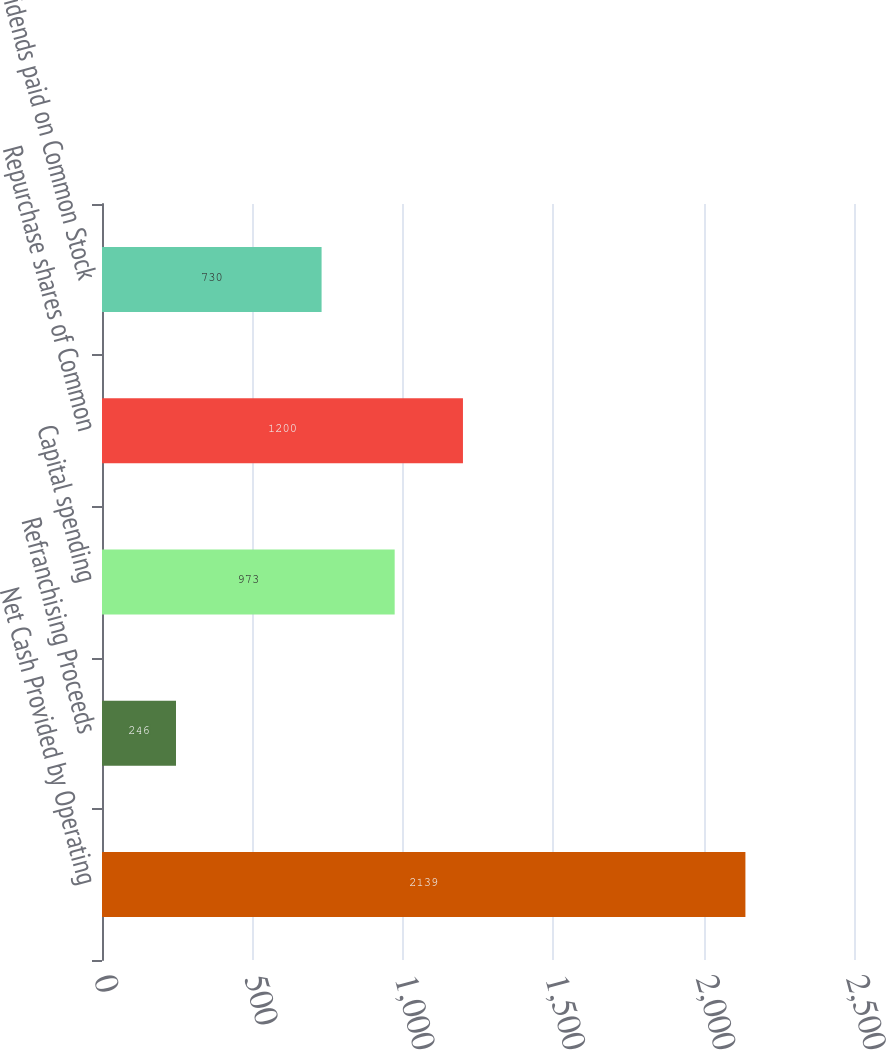<chart> <loc_0><loc_0><loc_500><loc_500><bar_chart><fcel>Net Cash Provided by Operating<fcel>Refranchising Proceeds<fcel>Capital spending<fcel>Repurchase shares of Common<fcel>Dividends paid on Common Stock<nl><fcel>2139<fcel>246<fcel>973<fcel>1200<fcel>730<nl></chart> 